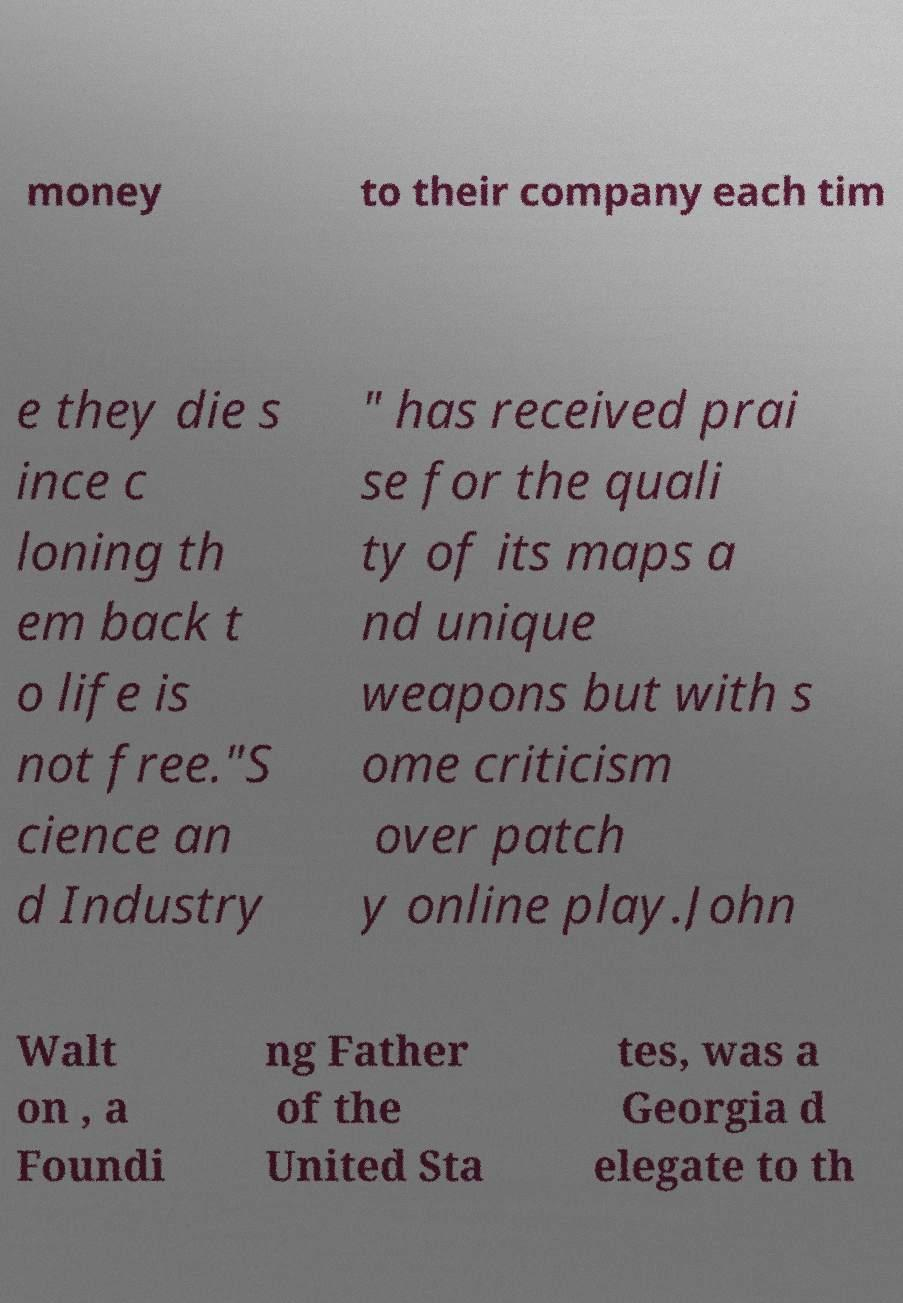Can you accurately transcribe the text from the provided image for me? money to their company each tim e they die s ince c loning th em back t o life is not free."S cience an d Industry " has received prai se for the quali ty of its maps a nd unique weapons but with s ome criticism over patch y online play.John Walt on , a Foundi ng Father of the United Sta tes, was a Georgia d elegate to th 